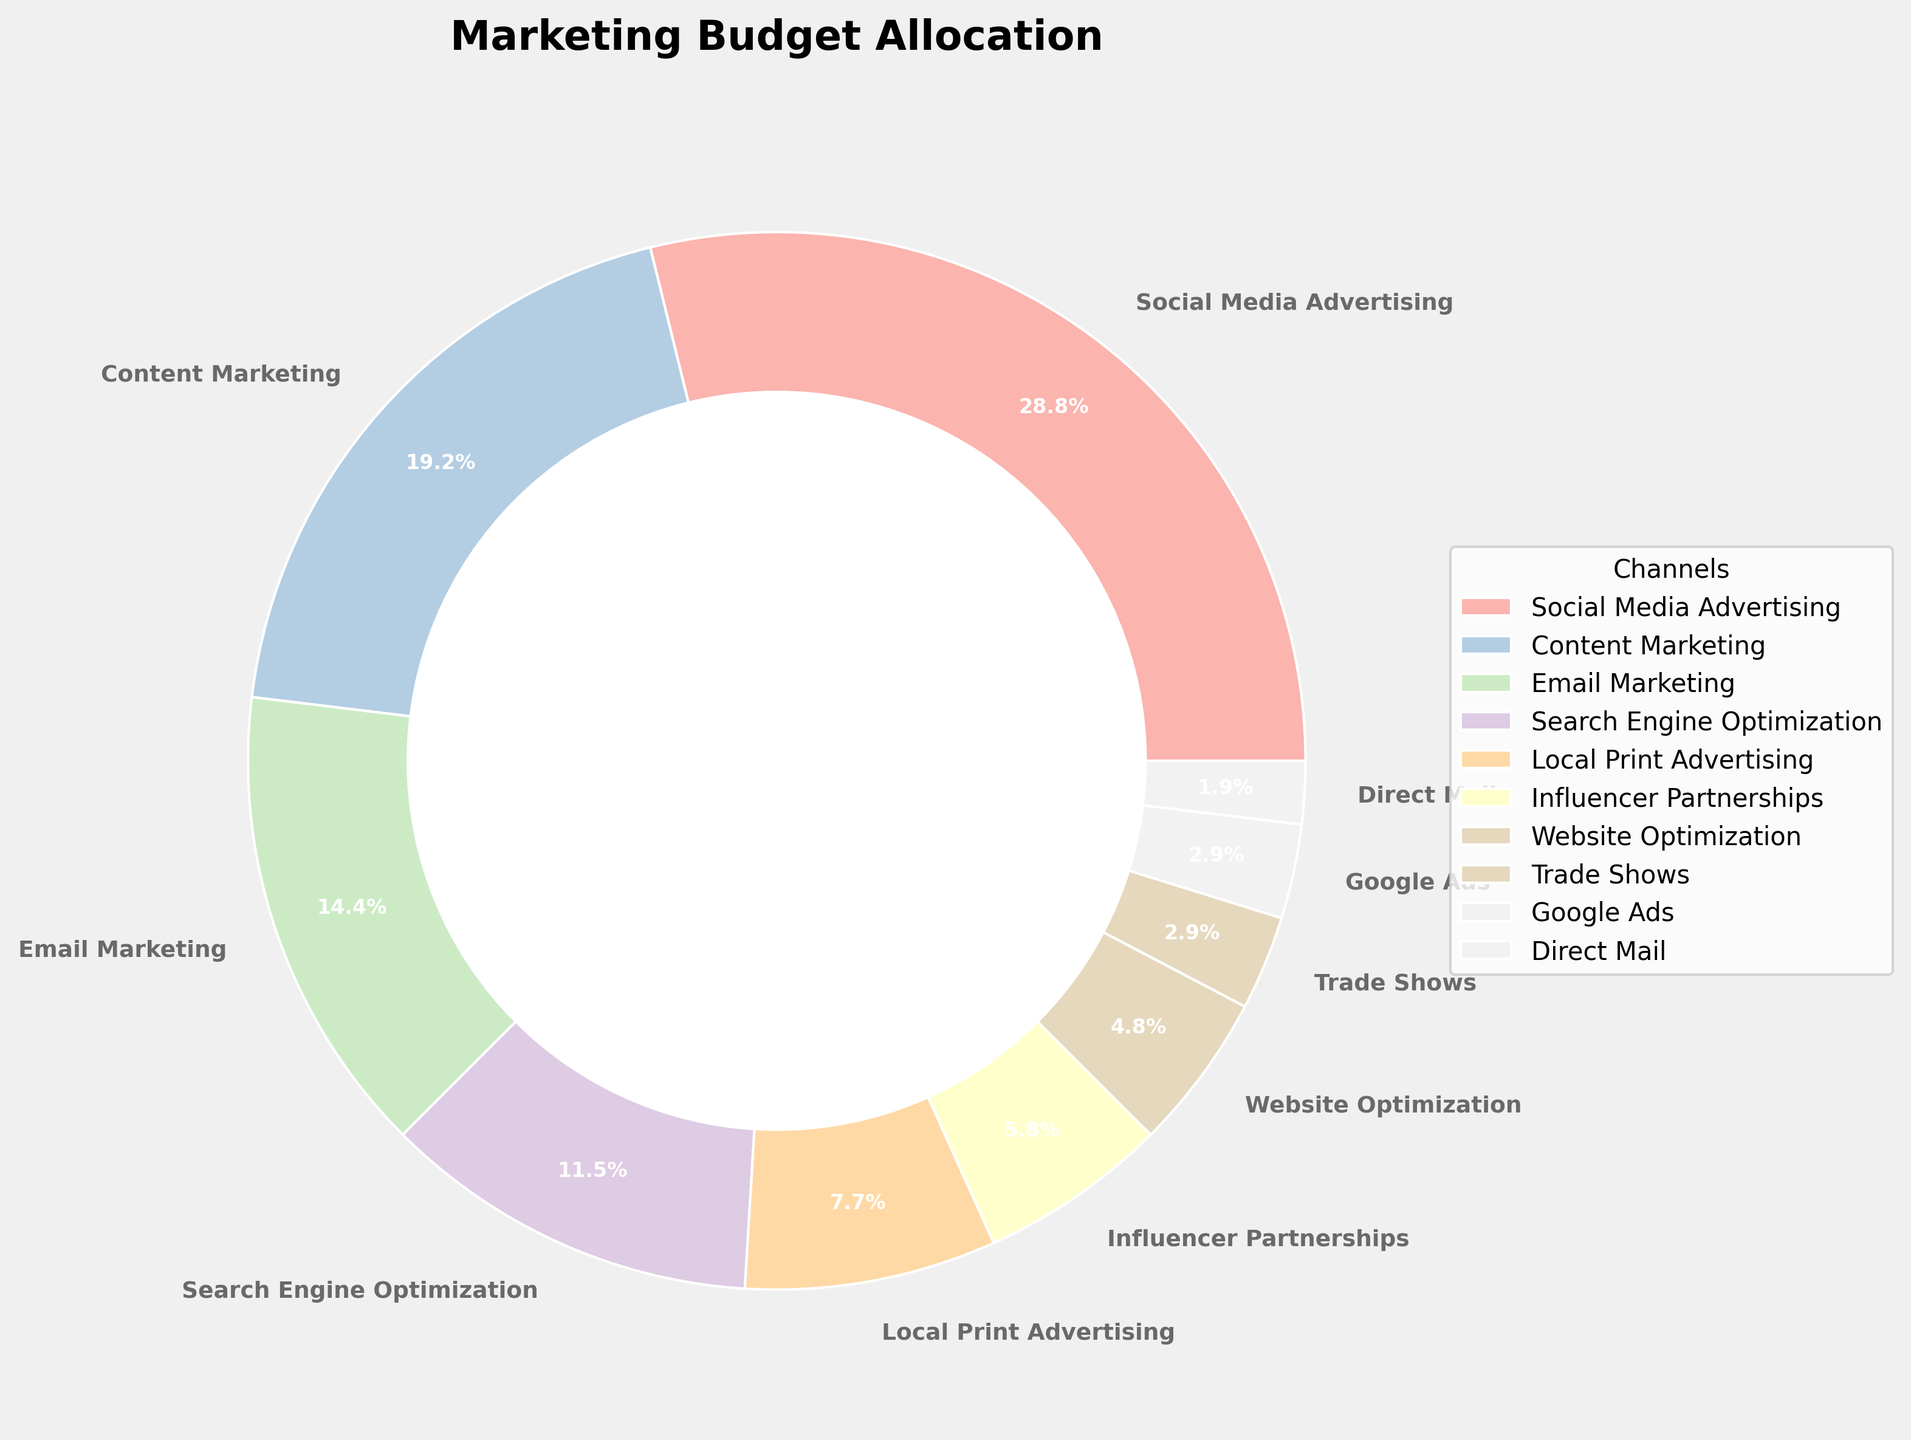What is the channel with the highest percentage allocation? Look at the chart for the largest wedge or segment of the pie. The largest segment belongs to "Social Media Advertising"
Answer: Social Media Advertising What is the combined percentage of Search Engine Optimization and Website Optimization? Sum the percentages associated with Search Engine Optimization and Website Optimization from the chart, 12% + 5% = 17%
Answer: 17% Which marketing channels have an allocation of less than 5%? Identify the segments of the pie chart that are labeled with percentages less than 5%. These are Trade Shows, Google Ads, and Direct Mail
Answer: Trade Shows, Google Ads, Direct Mail How does the allocation for Content Marketing compare with Email Marketing? Compare the percentages: Content Marketing is 20% and Email Marketing is 15%. Content Marketing has a higher allocation than Email Marketing
Answer: Content Marketing has a higher allocation What is the percentage difference between Social Media Advertising and Local Print Advertising? Subtract the percentage of Local Print Advertising from Social Media Advertising: 30% - 8% = 22%
Answer: 22% Which segment is represented by the color representing Influencer Partnerships? Identify the color associated with Influencer Partnerships in the legend and locate the corresponding segment on the pie chart
Answer: The segment represented by the light green color What are the three largest allocations in order and their combined percentage? Identify and sum up the three largest percentages in the pie chart: Social Media Advertising (30%), Content Marketing (20%), and Email Marketing (15%). Combined percentage is 30% + 20% + 15% = 65%
Answer: Social Media Advertising, Content Marketing, Email Marketing, 65% Between Google Ads and Trade Shows, which has a smaller percentage allocation, and by how much? Google Ads is 3% and Trade Shows are also 3%, hence both have equal allocation, so the difference is 0%
Answer: They have equal allocation, 0% What is the percentage share of all digital-related marketing channels combined (e.g., Social Media, Content, Email, SEO, Website Optimization, Google Ads)? Sum the percentages of all the mentioned digital-related marketing channels: 30% + 20% + 15% + 12% + 5% + 3% = 85%
Answer: 85% 